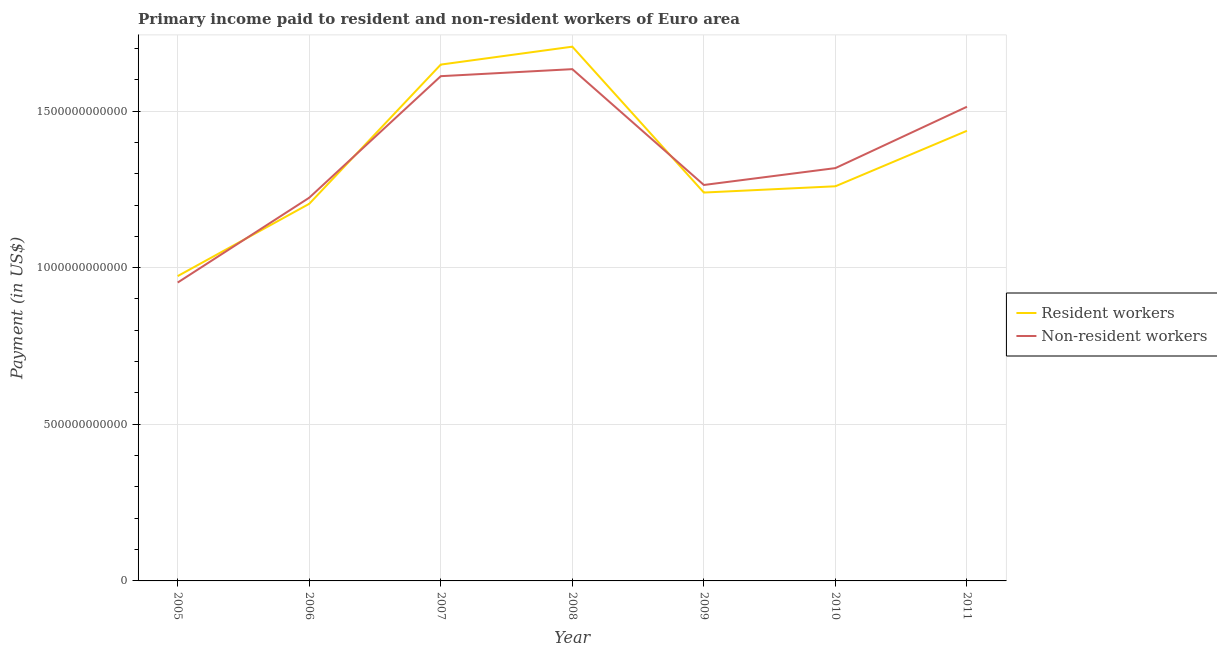What is the payment made to resident workers in 2011?
Offer a very short reply. 1.44e+12. Across all years, what is the maximum payment made to resident workers?
Ensure brevity in your answer.  1.71e+12. Across all years, what is the minimum payment made to resident workers?
Keep it short and to the point. 9.73e+11. In which year was the payment made to resident workers maximum?
Offer a very short reply. 2008. In which year was the payment made to resident workers minimum?
Your answer should be very brief. 2005. What is the total payment made to non-resident workers in the graph?
Provide a short and direct response. 9.52e+12. What is the difference between the payment made to resident workers in 2008 and that in 2011?
Offer a very short reply. 2.69e+11. What is the difference between the payment made to resident workers in 2007 and the payment made to non-resident workers in 2010?
Offer a terse response. 3.30e+11. What is the average payment made to non-resident workers per year?
Your response must be concise. 1.36e+12. In the year 2008, what is the difference between the payment made to resident workers and payment made to non-resident workers?
Your answer should be very brief. 7.18e+1. What is the ratio of the payment made to non-resident workers in 2005 to that in 2006?
Ensure brevity in your answer.  0.78. Is the payment made to resident workers in 2007 less than that in 2011?
Offer a very short reply. No. Is the difference between the payment made to resident workers in 2005 and 2009 greater than the difference between the payment made to non-resident workers in 2005 and 2009?
Keep it short and to the point. Yes. What is the difference between the highest and the second highest payment made to resident workers?
Provide a succinct answer. 5.72e+1. What is the difference between the highest and the lowest payment made to resident workers?
Make the answer very short. 7.32e+11. Is the sum of the payment made to resident workers in 2005 and 2006 greater than the maximum payment made to non-resident workers across all years?
Offer a terse response. Yes. Is the payment made to resident workers strictly greater than the payment made to non-resident workers over the years?
Provide a succinct answer. No. Is the payment made to non-resident workers strictly less than the payment made to resident workers over the years?
Keep it short and to the point. No. What is the difference between two consecutive major ticks on the Y-axis?
Make the answer very short. 5.00e+11. Are the values on the major ticks of Y-axis written in scientific E-notation?
Offer a very short reply. No. Does the graph contain any zero values?
Provide a short and direct response. No. Does the graph contain grids?
Provide a short and direct response. Yes. How many legend labels are there?
Provide a succinct answer. 2. How are the legend labels stacked?
Ensure brevity in your answer.  Vertical. What is the title of the graph?
Provide a succinct answer. Primary income paid to resident and non-resident workers of Euro area. Does "Boys" appear as one of the legend labels in the graph?
Offer a very short reply. No. What is the label or title of the Y-axis?
Offer a very short reply. Payment (in US$). What is the Payment (in US$) in Resident workers in 2005?
Offer a terse response. 9.73e+11. What is the Payment (in US$) in Non-resident workers in 2005?
Offer a terse response. 9.52e+11. What is the Payment (in US$) of Resident workers in 2006?
Your answer should be very brief. 1.20e+12. What is the Payment (in US$) in Non-resident workers in 2006?
Your answer should be very brief. 1.22e+12. What is the Payment (in US$) of Resident workers in 2007?
Give a very brief answer. 1.65e+12. What is the Payment (in US$) of Non-resident workers in 2007?
Provide a succinct answer. 1.61e+12. What is the Payment (in US$) of Resident workers in 2008?
Provide a short and direct response. 1.71e+12. What is the Payment (in US$) of Non-resident workers in 2008?
Ensure brevity in your answer.  1.63e+12. What is the Payment (in US$) of Resident workers in 2009?
Keep it short and to the point. 1.24e+12. What is the Payment (in US$) of Non-resident workers in 2009?
Make the answer very short. 1.26e+12. What is the Payment (in US$) in Resident workers in 2010?
Provide a short and direct response. 1.26e+12. What is the Payment (in US$) of Non-resident workers in 2010?
Your answer should be very brief. 1.32e+12. What is the Payment (in US$) of Resident workers in 2011?
Keep it short and to the point. 1.44e+12. What is the Payment (in US$) of Non-resident workers in 2011?
Your answer should be very brief. 1.51e+12. Across all years, what is the maximum Payment (in US$) of Resident workers?
Ensure brevity in your answer.  1.71e+12. Across all years, what is the maximum Payment (in US$) of Non-resident workers?
Your answer should be very brief. 1.63e+12. Across all years, what is the minimum Payment (in US$) of Resident workers?
Ensure brevity in your answer.  9.73e+11. Across all years, what is the minimum Payment (in US$) in Non-resident workers?
Offer a very short reply. 9.52e+11. What is the total Payment (in US$) of Resident workers in the graph?
Your answer should be compact. 9.47e+12. What is the total Payment (in US$) of Non-resident workers in the graph?
Offer a terse response. 9.52e+12. What is the difference between the Payment (in US$) of Resident workers in 2005 and that in 2006?
Keep it short and to the point. -2.31e+11. What is the difference between the Payment (in US$) of Non-resident workers in 2005 and that in 2006?
Offer a very short reply. -2.71e+11. What is the difference between the Payment (in US$) in Resident workers in 2005 and that in 2007?
Your response must be concise. -6.75e+11. What is the difference between the Payment (in US$) of Non-resident workers in 2005 and that in 2007?
Keep it short and to the point. -6.59e+11. What is the difference between the Payment (in US$) of Resident workers in 2005 and that in 2008?
Offer a very short reply. -7.32e+11. What is the difference between the Payment (in US$) of Non-resident workers in 2005 and that in 2008?
Ensure brevity in your answer.  -6.81e+11. What is the difference between the Payment (in US$) of Resident workers in 2005 and that in 2009?
Ensure brevity in your answer.  -2.67e+11. What is the difference between the Payment (in US$) in Non-resident workers in 2005 and that in 2009?
Your answer should be compact. -3.11e+11. What is the difference between the Payment (in US$) of Resident workers in 2005 and that in 2010?
Give a very brief answer. -2.87e+11. What is the difference between the Payment (in US$) in Non-resident workers in 2005 and that in 2010?
Your response must be concise. -3.65e+11. What is the difference between the Payment (in US$) of Resident workers in 2005 and that in 2011?
Keep it short and to the point. -4.64e+11. What is the difference between the Payment (in US$) in Non-resident workers in 2005 and that in 2011?
Provide a short and direct response. -5.61e+11. What is the difference between the Payment (in US$) of Resident workers in 2006 and that in 2007?
Provide a short and direct response. -4.44e+11. What is the difference between the Payment (in US$) of Non-resident workers in 2006 and that in 2007?
Make the answer very short. -3.88e+11. What is the difference between the Payment (in US$) of Resident workers in 2006 and that in 2008?
Give a very brief answer. -5.02e+11. What is the difference between the Payment (in US$) in Non-resident workers in 2006 and that in 2008?
Your answer should be compact. -4.10e+11. What is the difference between the Payment (in US$) of Resident workers in 2006 and that in 2009?
Offer a very short reply. -3.60e+1. What is the difference between the Payment (in US$) of Non-resident workers in 2006 and that in 2009?
Keep it short and to the point. -4.07e+1. What is the difference between the Payment (in US$) in Resident workers in 2006 and that in 2010?
Give a very brief answer. -5.60e+1. What is the difference between the Payment (in US$) in Non-resident workers in 2006 and that in 2010?
Provide a succinct answer. -9.45e+1. What is the difference between the Payment (in US$) in Resident workers in 2006 and that in 2011?
Your answer should be compact. -2.33e+11. What is the difference between the Payment (in US$) in Non-resident workers in 2006 and that in 2011?
Offer a very short reply. -2.90e+11. What is the difference between the Payment (in US$) in Resident workers in 2007 and that in 2008?
Your response must be concise. -5.72e+1. What is the difference between the Payment (in US$) of Non-resident workers in 2007 and that in 2008?
Offer a terse response. -2.24e+1. What is the difference between the Payment (in US$) of Resident workers in 2007 and that in 2009?
Give a very brief answer. 4.08e+11. What is the difference between the Payment (in US$) of Non-resident workers in 2007 and that in 2009?
Offer a very short reply. 3.47e+11. What is the difference between the Payment (in US$) of Resident workers in 2007 and that in 2010?
Offer a very short reply. 3.88e+11. What is the difference between the Payment (in US$) in Non-resident workers in 2007 and that in 2010?
Your response must be concise. 2.93e+11. What is the difference between the Payment (in US$) of Resident workers in 2007 and that in 2011?
Provide a succinct answer. 2.11e+11. What is the difference between the Payment (in US$) in Non-resident workers in 2007 and that in 2011?
Give a very brief answer. 9.76e+1. What is the difference between the Payment (in US$) in Resident workers in 2008 and that in 2009?
Ensure brevity in your answer.  4.66e+11. What is the difference between the Payment (in US$) in Non-resident workers in 2008 and that in 2009?
Ensure brevity in your answer.  3.70e+11. What is the difference between the Payment (in US$) in Resident workers in 2008 and that in 2010?
Your answer should be very brief. 4.46e+11. What is the difference between the Payment (in US$) in Non-resident workers in 2008 and that in 2010?
Offer a terse response. 3.16e+11. What is the difference between the Payment (in US$) of Resident workers in 2008 and that in 2011?
Your answer should be compact. 2.69e+11. What is the difference between the Payment (in US$) of Non-resident workers in 2008 and that in 2011?
Offer a terse response. 1.20e+11. What is the difference between the Payment (in US$) in Resident workers in 2009 and that in 2010?
Offer a terse response. -2.00e+1. What is the difference between the Payment (in US$) of Non-resident workers in 2009 and that in 2010?
Keep it short and to the point. -5.39e+1. What is the difference between the Payment (in US$) in Resident workers in 2009 and that in 2011?
Ensure brevity in your answer.  -1.97e+11. What is the difference between the Payment (in US$) in Non-resident workers in 2009 and that in 2011?
Offer a terse response. -2.50e+11. What is the difference between the Payment (in US$) in Resident workers in 2010 and that in 2011?
Give a very brief answer. -1.77e+11. What is the difference between the Payment (in US$) of Non-resident workers in 2010 and that in 2011?
Ensure brevity in your answer.  -1.96e+11. What is the difference between the Payment (in US$) of Resident workers in 2005 and the Payment (in US$) of Non-resident workers in 2006?
Provide a succinct answer. -2.50e+11. What is the difference between the Payment (in US$) of Resident workers in 2005 and the Payment (in US$) of Non-resident workers in 2007?
Your response must be concise. -6.38e+11. What is the difference between the Payment (in US$) in Resident workers in 2005 and the Payment (in US$) in Non-resident workers in 2008?
Make the answer very short. -6.61e+11. What is the difference between the Payment (in US$) in Resident workers in 2005 and the Payment (in US$) in Non-resident workers in 2009?
Your answer should be very brief. -2.91e+11. What is the difference between the Payment (in US$) in Resident workers in 2005 and the Payment (in US$) in Non-resident workers in 2010?
Offer a very short reply. -3.45e+11. What is the difference between the Payment (in US$) in Resident workers in 2005 and the Payment (in US$) in Non-resident workers in 2011?
Give a very brief answer. -5.41e+11. What is the difference between the Payment (in US$) in Resident workers in 2006 and the Payment (in US$) in Non-resident workers in 2007?
Offer a terse response. -4.07e+11. What is the difference between the Payment (in US$) in Resident workers in 2006 and the Payment (in US$) in Non-resident workers in 2008?
Your answer should be compact. -4.30e+11. What is the difference between the Payment (in US$) of Resident workers in 2006 and the Payment (in US$) of Non-resident workers in 2009?
Your answer should be compact. -6.02e+1. What is the difference between the Payment (in US$) of Resident workers in 2006 and the Payment (in US$) of Non-resident workers in 2010?
Provide a succinct answer. -1.14e+11. What is the difference between the Payment (in US$) of Resident workers in 2006 and the Payment (in US$) of Non-resident workers in 2011?
Keep it short and to the point. -3.10e+11. What is the difference between the Payment (in US$) of Resident workers in 2007 and the Payment (in US$) of Non-resident workers in 2008?
Make the answer very short. 1.46e+1. What is the difference between the Payment (in US$) in Resident workers in 2007 and the Payment (in US$) in Non-resident workers in 2009?
Make the answer very short. 3.84e+11. What is the difference between the Payment (in US$) of Resident workers in 2007 and the Payment (in US$) of Non-resident workers in 2010?
Your answer should be very brief. 3.30e+11. What is the difference between the Payment (in US$) of Resident workers in 2007 and the Payment (in US$) of Non-resident workers in 2011?
Keep it short and to the point. 1.35e+11. What is the difference between the Payment (in US$) of Resident workers in 2008 and the Payment (in US$) of Non-resident workers in 2009?
Your response must be concise. 4.41e+11. What is the difference between the Payment (in US$) of Resident workers in 2008 and the Payment (in US$) of Non-resident workers in 2010?
Ensure brevity in your answer.  3.88e+11. What is the difference between the Payment (in US$) in Resident workers in 2008 and the Payment (in US$) in Non-resident workers in 2011?
Make the answer very short. 1.92e+11. What is the difference between the Payment (in US$) in Resident workers in 2009 and the Payment (in US$) in Non-resident workers in 2010?
Your answer should be very brief. -7.80e+1. What is the difference between the Payment (in US$) in Resident workers in 2009 and the Payment (in US$) in Non-resident workers in 2011?
Provide a short and direct response. -2.74e+11. What is the difference between the Payment (in US$) of Resident workers in 2010 and the Payment (in US$) of Non-resident workers in 2011?
Provide a succinct answer. -2.54e+11. What is the average Payment (in US$) of Resident workers per year?
Ensure brevity in your answer.  1.35e+12. What is the average Payment (in US$) of Non-resident workers per year?
Ensure brevity in your answer.  1.36e+12. In the year 2005, what is the difference between the Payment (in US$) of Resident workers and Payment (in US$) of Non-resident workers?
Make the answer very short. 2.06e+1. In the year 2006, what is the difference between the Payment (in US$) of Resident workers and Payment (in US$) of Non-resident workers?
Provide a succinct answer. -1.95e+1. In the year 2007, what is the difference between the Payment (in US$) of Resident workers and Payment (in US$) of Non-resident workers?
Give a very brief answer. 3.70e+1. In the year 2008, what is the difference between the Payment (in US$) of Resident workers and Payment (in US$) of Non-resident workers?
Your response must be concise. 7.18e+1. In the year 2009, what is the difference between the Payment (in US$) in Resident workers and Payment (in US$) in Non-resident workers?
Make the answer very short. -2.42e+1. In the year 2010, what is the difference between the Payment (in US$) of Resident workers and Payment (in US$) of Non-resident workers?
Offer a very short reply. -5.80e+1. In the year 2011, what is the difference between the Payment (in US$) in Resident workers and Payment (in US$) in Non-resident workers?
Your response must be concise. -7.67e+1. What is the ratio of the Payment (in US$) of Resident workers in 2005 to that in 2006?
Give a very brief answer. 0.81. What is the ratio of the Payment (in US$) in Non-resident workers in 2005 to that in 2006?
Provide a succinct answer. 0.78. What is the ratio of the Payment (in US$) in Resident workers in 2005 to that in 2007?
Your answer should be very brief. 0.59. What is the ratio of the Payment (in US$) in Non-resident workers in 2005 to that in 2007?
Provide a succinct answer. 0.59. What is the ratio of the Payment (in US$) in Resident workers in 2005 to that in 2008?
Provide a short and direct response. 0.57. What is the ratio of the Payment (in US$) of Non-resident workers in 2005 to that in 2008?
Give a very brief answer. 0.58. What is the ratio of the Payment (in US$) of Resident workers in 2005 to that in 2009?
Offer a terse response. 0.78. What is the ratio of the Payment (in US$) in Non-resident workers in 2005 to that in 2009?
Provide a short and direct response. 0.75. What is the ratio of the Payment (in US$) of Resident workers in 2005 to that in 2010?
Ensure brevity in your answer.  0.77. What is the ratio of the Payment (in US$) of Non-resident workers in 2005 to that in 2010?
Your answer should be compact. 0.72. What is the ratio of the Payment (in US$) in Resident workers in 2005 to that in 2011?
Provide a short and direct response. 0.68. What is the ratio of the Payment (in US$) of Non-resident workers in 2005 to that in 2011?
Give a very brief answer. 0.63. What is the ratio of the Payment (in US$) in Resident workers in 2006 to that in 2007?
Provide a succinct answer. 0.73. What is the ratio of the Payment (in US$) of Non-resident workers in 2006 to that in 2007?
Offer a very short reply. 0.76. What is the ratio of the Payment (in US$) of Resident workers in 2006 to that in 2008?
Provide a short and direct response. 0.71. What is the ratio of the Payment (in US$) in Non-resident workers in 2006 to that in 2008?
Give a very brief answer. 0.75. What is the ratio of the Payment (in US$) in Resident workers in 2006 to that in 2009?
Your response must be concise. 0.97. What is the ratio of the Payment (in US$) in Non-resident workers in 2006 to that in 2009?
Keep it short and to the point. 0.97. What is the ratio of the Payment (in US$) in Resident workers in 2006 to that in 2010?
Your response must be concise. 0.96. What is the ratio of the Payment (in US$) in Non-resident workers in 2006 to that in 2010?
Give a very brief answer. 0.93. What is the ratio of the Payment (in US$) in Resident workers in 2006 to that in 2011?
Make the answer very short. 0.84. What is the ratio of the Payment (in US$) in Non-resident workers in 2006 to that in 2011?
Your response must be concise. 0.81. What is the ratio of the Payment (in US$) in Resident workers in 2007 to that in 2008?
Keep it short and to the point. 0.97. What is the ratio of the Payment (in US$) in Non-resident workers in 2007 to that in 2008?
Provide a succinct answer. 0.99. What is the ratio of the Payment (in US$) in Resident workers in 2007 to that in 2009?
Offer a terse response. 1.33. What is the ratio of the Payment (in US$) of Non-resident workers in 2007 to that in 2009?
Give a very brief answer. 1.27. What is the ratio of the Payment (in US$) of Resident workers in 2007 to that in 2010?
Give a very brief answer. 1.31. What is the ratio of the Payment (in US$) in Non-resident workers in 2007 to that in 2010?
Your answer should be compact. 1.22. What is the ratio of the Payment (in US$) in Resident workers in 2007 to that in 2011?
Ensure brevity in your answer.  1.15. What is the ratio of the Payment (in US$) in Non-resident workers in 2007 to that in 2011?
Provide a short and direct response. 1.06. What is the ratio of the Payment (in US$) of Resident workers in 2008 to that in 2009?
Ensure brevity in your answer.  1.38. What is the ratio of the Payment (in US$) in Non-resident workers in 2008 to that in 2009?
Give a very brief answer. 1.29. What is the ratio of the Payment (in US$) in Resident workers in 2008 to that in 2010?
Provide a succinct answer. 1.35. What is the ratio of the Payment (in US$) of Non-resident workers in 2008 to that in 2010?
Provide a succinct answer. 1.24. What is the ratio of the Payment (in US$) of Resident workers in 2008 to that in 2011?
Provide a succinct answer. 1.19. What is the ratio of the Payment (in US$) in Non-resident workers in 2008 to that in 2011?
Offer a terse response. 1.08. What is the ratio of the Payment (in US$) in Resident workers in 2009 to that in 2010?
Provide a short and direct response. 0.98. What is the ratio of the Payment (in US$) of Non-resident workers in 2009 to that in 2010?
Make the answer very short. 0.96. What is the ratio of the Payment (in US$) in Resident workers in 2009 to that in 2011?
Your answer should be very brief. 0.86. What is the ratio of the Payment (in US$) in Non-resident workers in 2009 to that in 2011?
Your answer should be compact. 0.83. What is the ratio of the Payment (in US$) of Resident workers in 2010 to that in 2011?
Make the answer very short. 0.88. What is the ratio of the Payment (in US$) in Non-resident workers in 2010 to that in 2011?
Give a very brief answer. 0.87. What is the difference between the highest and the second highest Payment (in US$) in Resident workers?
Provide a short and direct response. 5.72e+1. What is the difference between the highest and the second highest Payment (in US$) in Non-resident workers?
Make the answer very short. 2.24e+1. What is the difference between the highest and the lowest Payment (in US$) of Resident workers?
Ensure brevity in your answer.  7.32e+11. What is the difference between the highest and the lowest Payment (in US$) in Non-resident workers?
Your answer should be very brief. 6.81e+11. 